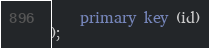Convert code to text. <code><loc_0><loc_0><loc_500><loc_500><_SQL_>    primary key (id)
);
</code> 